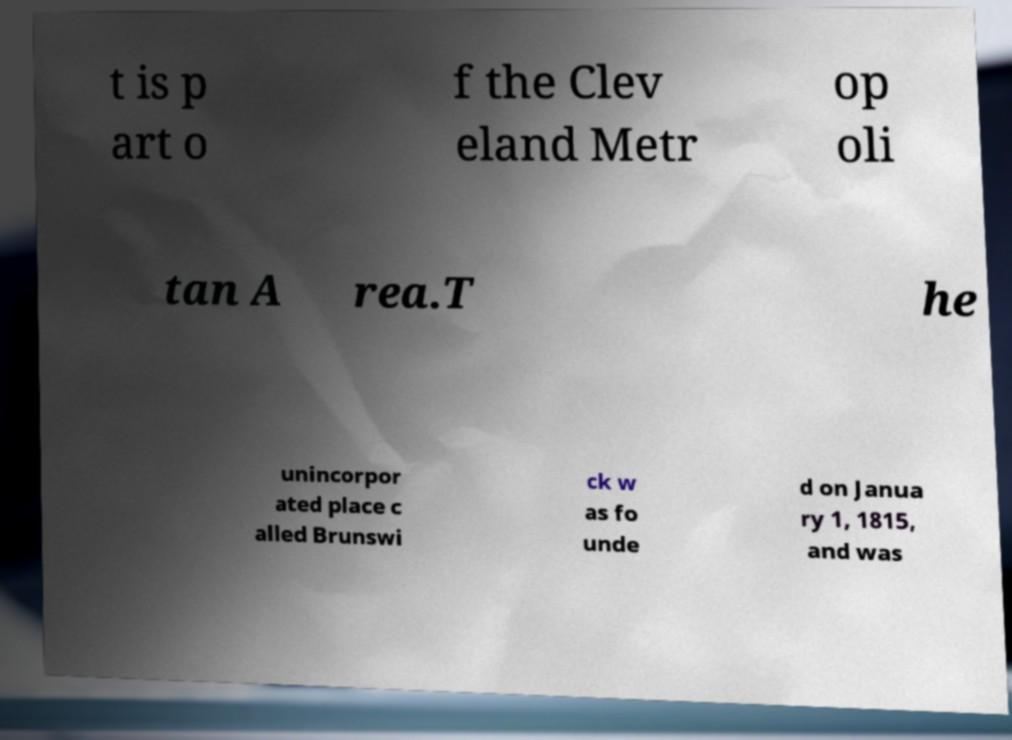For documentation purposes, I need the text within this image transcribed. Could you provide that? t is p art o f the Clev eland Metr op oli tan A rea.T he unincorpor ated place c alled Brunswi ck w as fo unde d on Janua ry 1, 1815, and was 